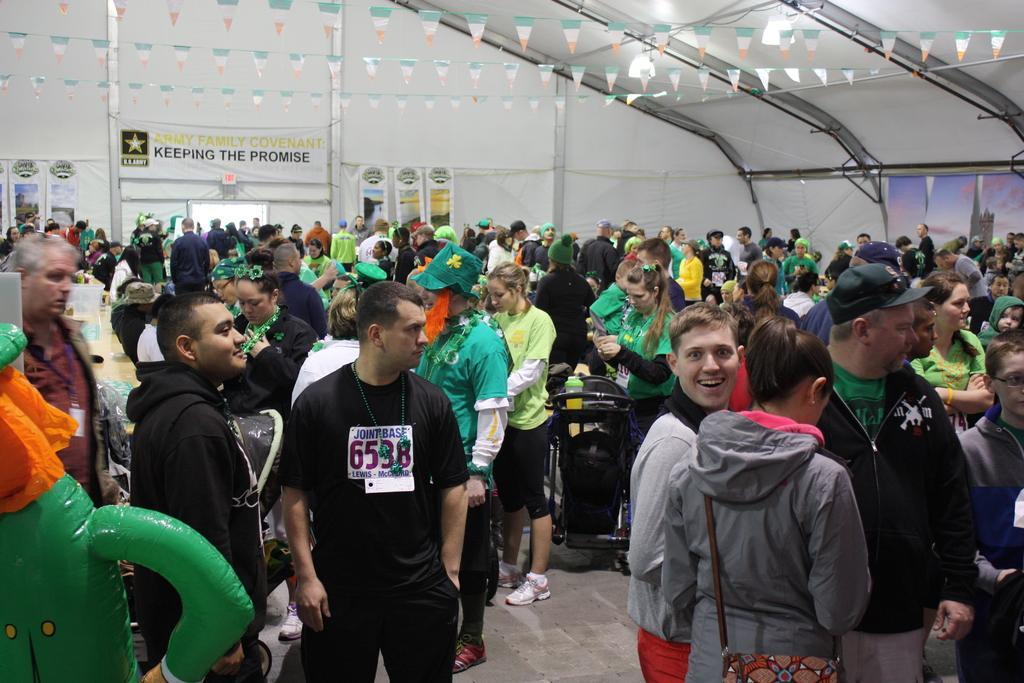Please provide a concise description of this image. This picture is clicked inside a room. There are many people standing. To the left there is a table. In the background there is the wall. There are banners on the wall. 